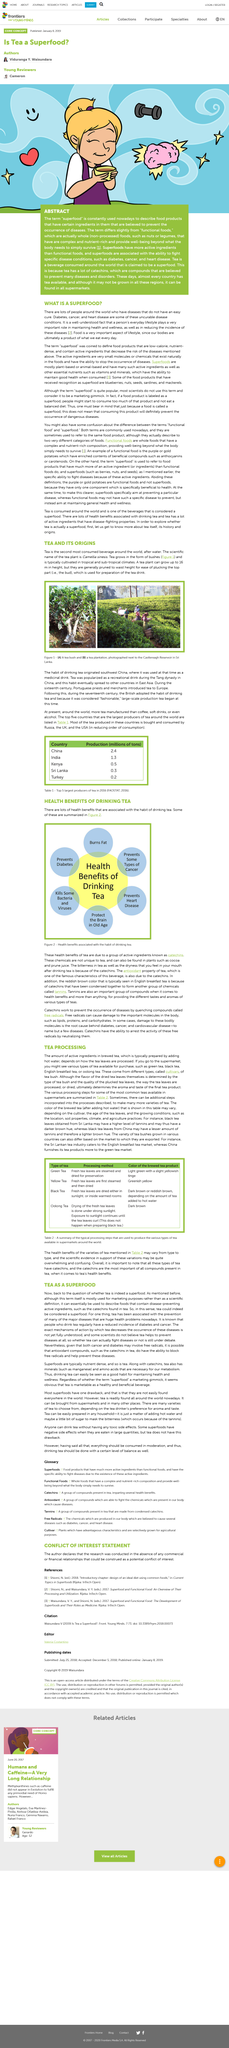Highlight a few significant elements in this photo. Different types of tea include green tea, yellow tea, black tea, and oolong tea. The habit of drinking tea originated in Southwest China. Figure 1B depicts a tea plantation located adjacent to the Castlereagh Reservoir in Sri Lanka. Figure 1A depicts a tea bush. The chemical content of black tea from Sri Lanka, particularly its tannins content, tends to be higher than that of other types of tea. 